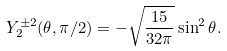<formula> <loc_0><loc_0><loc_500><loc_500>Y _ { 2 } ^ { \pm 2 } ( \theta , \pi / 2 ) = - \sqrt { \frac { 1 5 } { 3 2 \pi } } \sin ^ { 2 } \theta .</formula> 